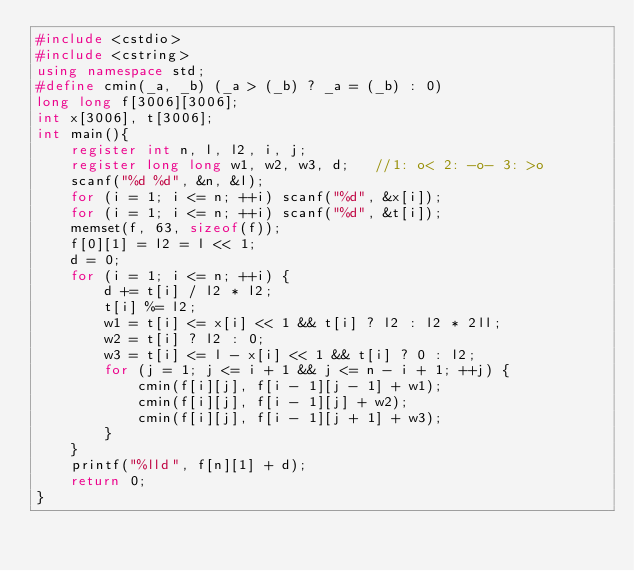<code> <loc_0><loc_0><loc_500><loc_500><_C++_>#include <cstdio>
#include <cstring>
using namespace std;
#define cmin(_a, _b) (_a > (_b) ? _a = (_b) : 0)
long long f[3006][3006];
int x[3006], t[3006];
int main(){
	register int n, l, l2, i, j;
	register long long w1, w2, w3, d;	//1: o< 2: -o- 3: >o
	scanf("%d %d", &n, &l);
	for (i = 1; i <= n; ++i) scanf("%d", &x[i]);
	for (i = 1; i <= n; ++i) scanf("%d", &t[i]);
	memset(f, 63, sizeof(f));
	f[0][1] = l2 = l << 1;
	d = 0;
	for (i = 1; i <= n; ++i) {
		d += t[i] / l2 * l2;
		t[i] %= l2;
		w1 = t[i] <= x[i] << 1 && t[i] ? l2 : l2 * 2ll;
		w2 = t[i] ? l2 : 0;
		w3 = t[i] <= l - x[i] << 1 && t[i] ? 0 : l2;
		for (j = 1; j <= i + 1 && j <= n - i + 1; ++j) {
			cmin(f[i][j], f[i - 1][j - 1] + w1);
			cmin(f[i][j], f[i - 1][j] + w2);
			cmin(f[i][j], f[i - 1][j + 1] + w3);
		}
	}
	printf("%lld", f[n][1] + d);
	return 0;
}</code> 